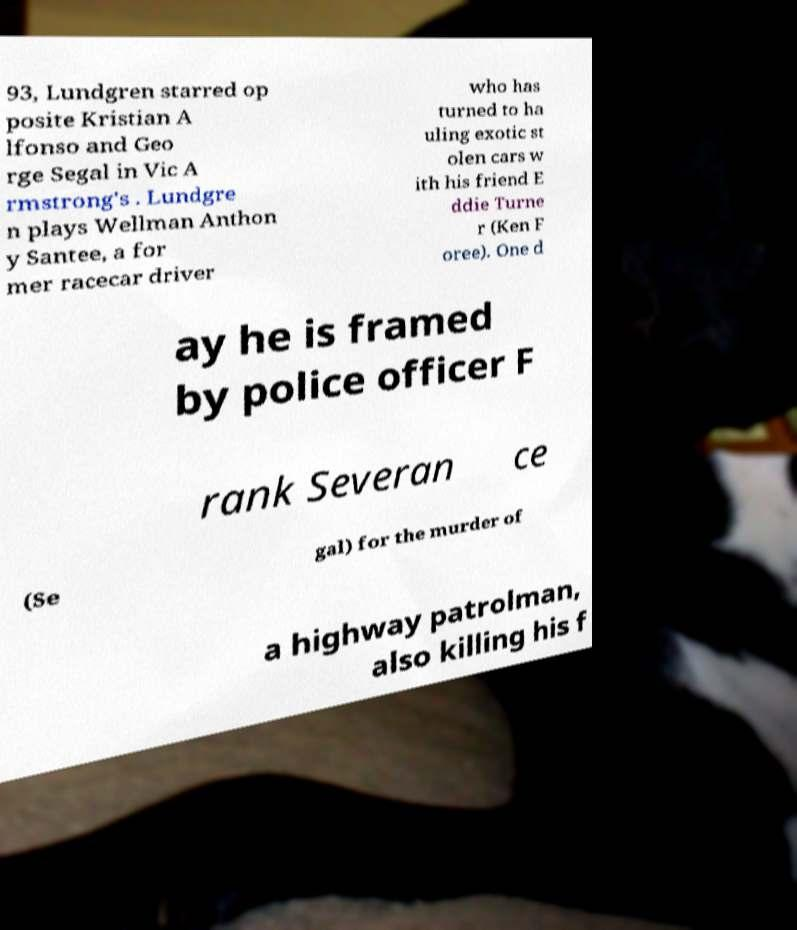Please identify and transcribe the text found in this image. 93, Lundgren starred op posite Kristian A lfonso and Geo rge Segal in Vic A rmstrong's . Lundgre n plays Wellman Anthon y Santee, a for mer racecar driver who has turned to ha uling exotic st olen cars w ith his friend E ddie Turne r (Ken F oree). One d ay he is framed by police officer F rank Severan ce (Se gal) for the murder of a highway patrolman, also killing his f 